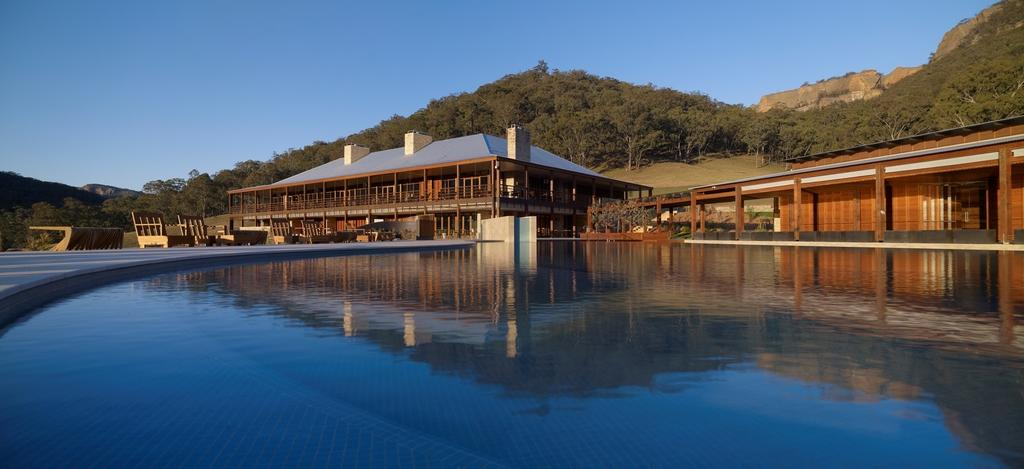What is the primary element visible in the image? There is water in the image. What type of surface can be seen beneath the water? There is ground visible in the image. Are there any man-made structures in the image? Yes, there are benches and buildings in the image. What can be seen in the distance in the image? There are mountains, trees, and the sky visible in the background of the image. What type of school can be seen in the image? There is no school present in the image. Can you tell me which judge is presiding over the case in the image? There is no courtroom or judge present in the image. 